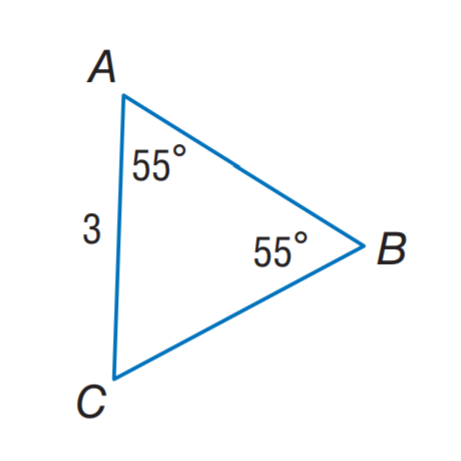Answer the mathemtical geometry problem and directly provide the correct option letter.
Question: Find C B.
Choices: A: 2 B: 3 C: 4 D: 55 B 